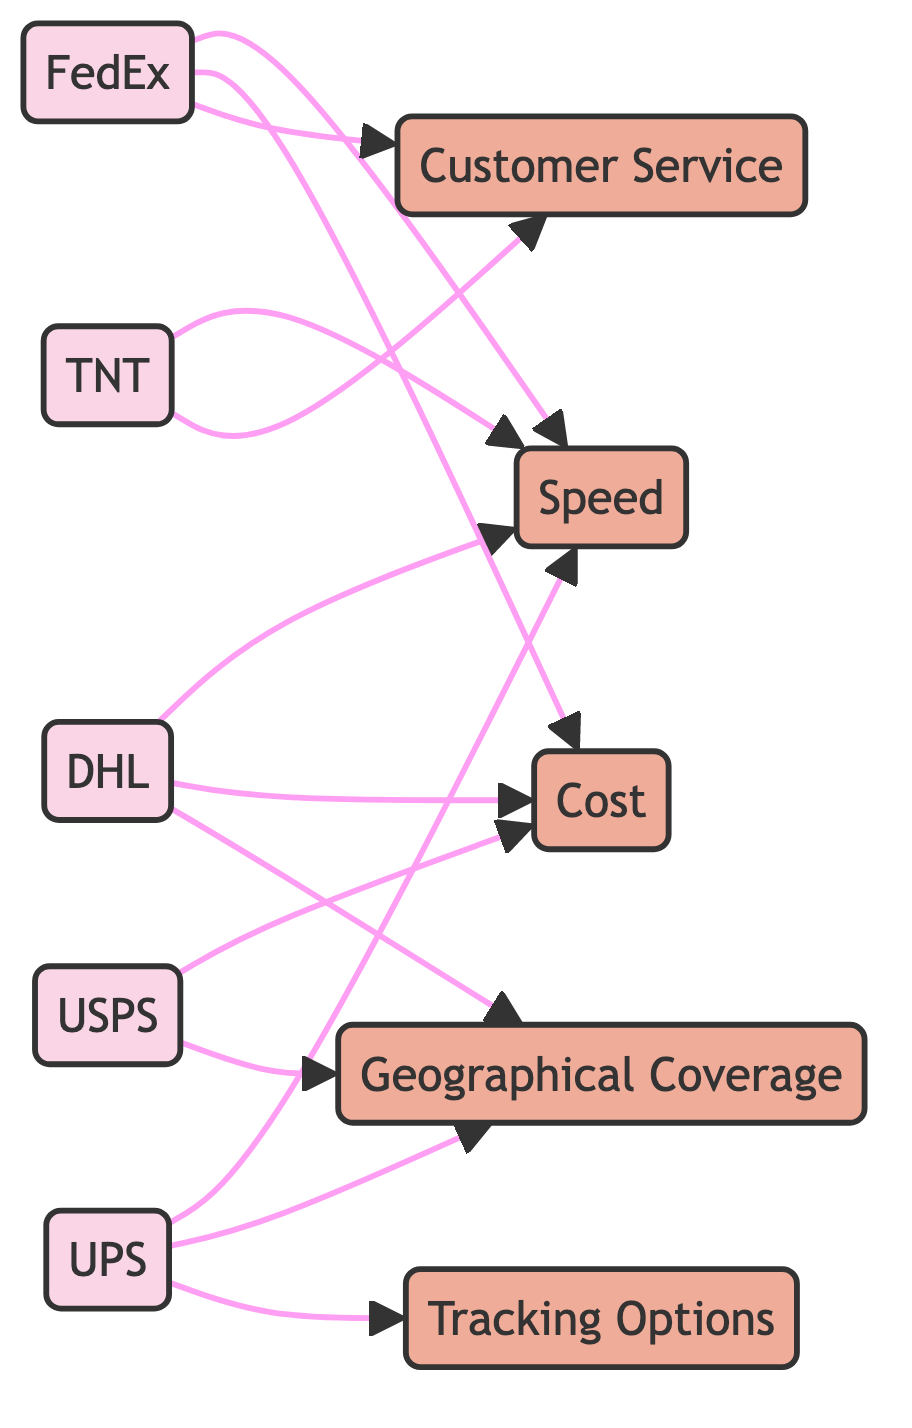What couriers are connected to Speed? By examining the arrows leading away from the Speed node, we can identify that DHL, FedEx, UPS, and TNT all have direct connections to Speed. These connections indicate that these couriers are associated with the Speed feature.
Answer: DHL, FedEx, UPS, TNT Which courier is linked to Customer Service? Looking at the diagram, we see that FedEx and TNT point to the Customer Service node, which shows that these couriers offer services related to Customer Service.
Answer: FedEx, TNT How many total couriers are represented in the diagram? Each courier node (DHL, FedEx, UPS, USPS, TNT) counts as one, and there are five distinct courier nodes depicted in the diagram.
Answer: Five Which feature is associated with both USPS and Coverage? The diagram shows that both USPS and Coverage are connected through an arrow indicating a relationship. Thus, the feature that is common to both is Coverage.
Answer: Coverage Which courier has the most connections in the diagram? From analyzing the connections drawn from each courier, we identify that DHL has three outgoing arrows (connected to Speed, Cost, and Coverage), which is the most amongst all couriers.
Answer: DHL What features do UPS and TNT have in common? By observing the connections from UPS and TNT, we see that UPS connects to Speed and Coverage while TNT connects to Speed and Customer Service. The only feature they share is Speed, which connects both couriers.
Answer: Speed Which courier is exclusively linked to Cost? Examining the diagram, we see that USPS is the only courier that has a direct connection to Cost without sharing that link with any other feature or courier.
Answer: USPS How many features are connected to FedEx? Inspecting the edges from FedEx, we find that it has connections to three features: Speed, Cost, and Customer Service. Therefore, the count of features linked to FedEx is three.
Answer: Three Which feature has the highest number of connecting couriers? Analyzing the diagram, we find that Speed is connected to four couriers (DHL, FedEx, UPS, and TNT), making it the feature with the most connections.
Answer: Speed 